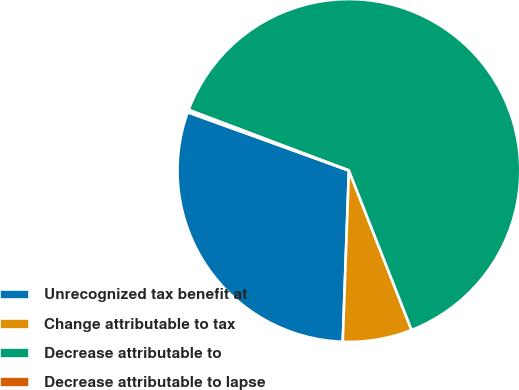Convert chart to OTSL. <chart><loc_0><loc_0><loc_500><loc_500><pie_chart><fcel>Unrecognized tax benefit at<fcel>Change attributable to tax<fcel>Decrease attributable to<fcel>Decrease attributable to lapse<nl><fcel>29.95%<fcel>6.53%<fcel>63.29%<fcel>0.23%<nl></chart> 